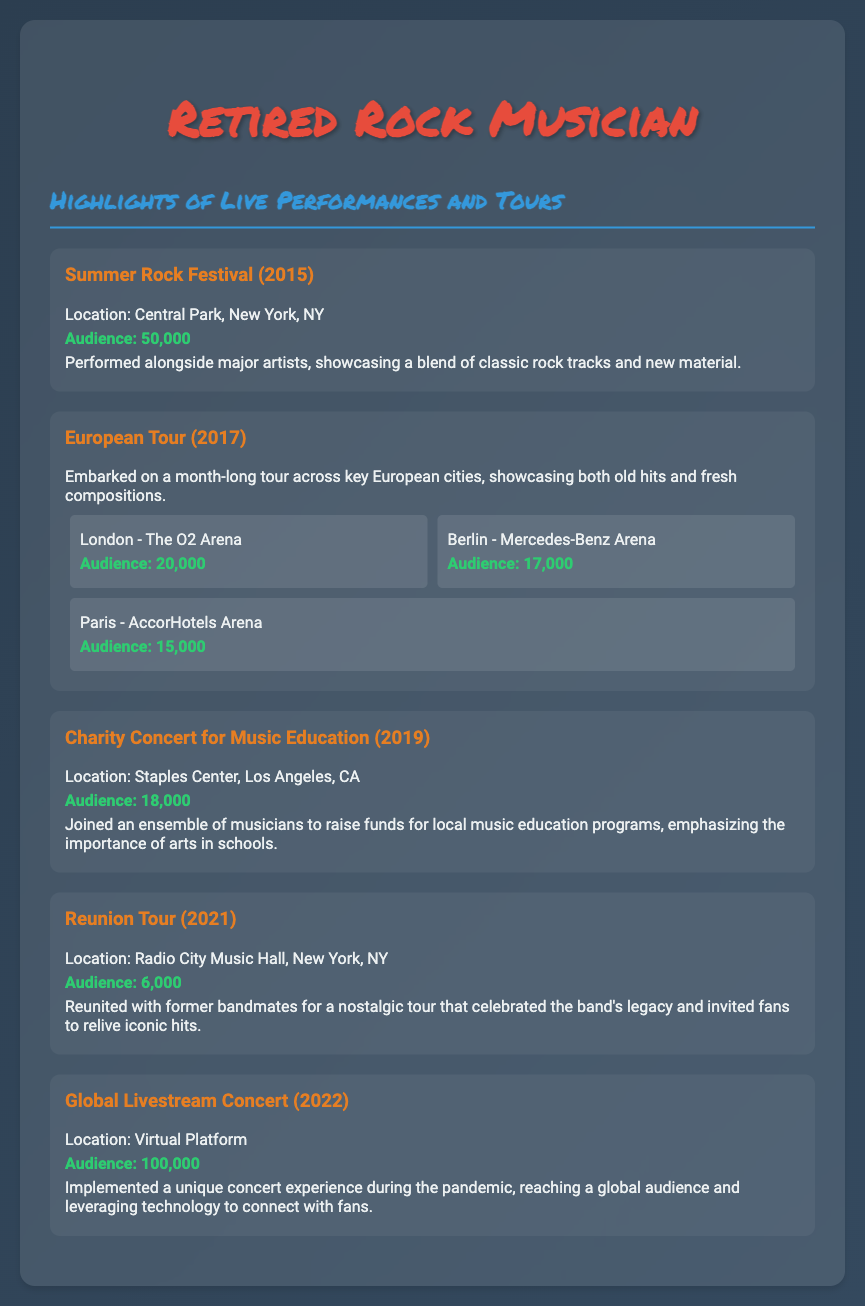What was the largest audience size? The largest audience size is specified in the Global Livestream Concert, which had 100,000 attendees.
Answer: 100,000 Where did the Summer Rock Festival take place? The location of the Summer Rock Festival is provided in the document as Central Park, New York, NY.
Answer: Central Park, New York, NY In which year did the Reunion Tour occur? The document mentions that the Reunion Tour took place in 2021, which is a specific year.
Answer: 2021 How many venues were mentioned during the European Tour? The document outlines three specific venues as part of the European Tour.
Answer: Three What was the purpose of the Charity Concert for Music Education? The document states that the concert aimed to raise funds for local music education programs.
Answer: Raise funds for music education Which city featured the concert at the Mercedes-Benz Arena? The document identifies Berlin as the city where the Mercedes-Benz Arena is located, which hosted an event during the European Tour.
Answer: Berlin What kind of concert was held in 2022? The document describes the 2022 event as a Global Livestream Concert, employing technology for a unique experience.
Answer: Global Livestream Concert How many locations were listed for the European Tour? The European Tour showcases three specific locations in the document, providing a clear count of venues.
Answer: Three Which concert had the smallest audience size? The Reunion Tour is noted in the document as having an audience size of 6,000, which is the smallest.
Answer: 6,000 